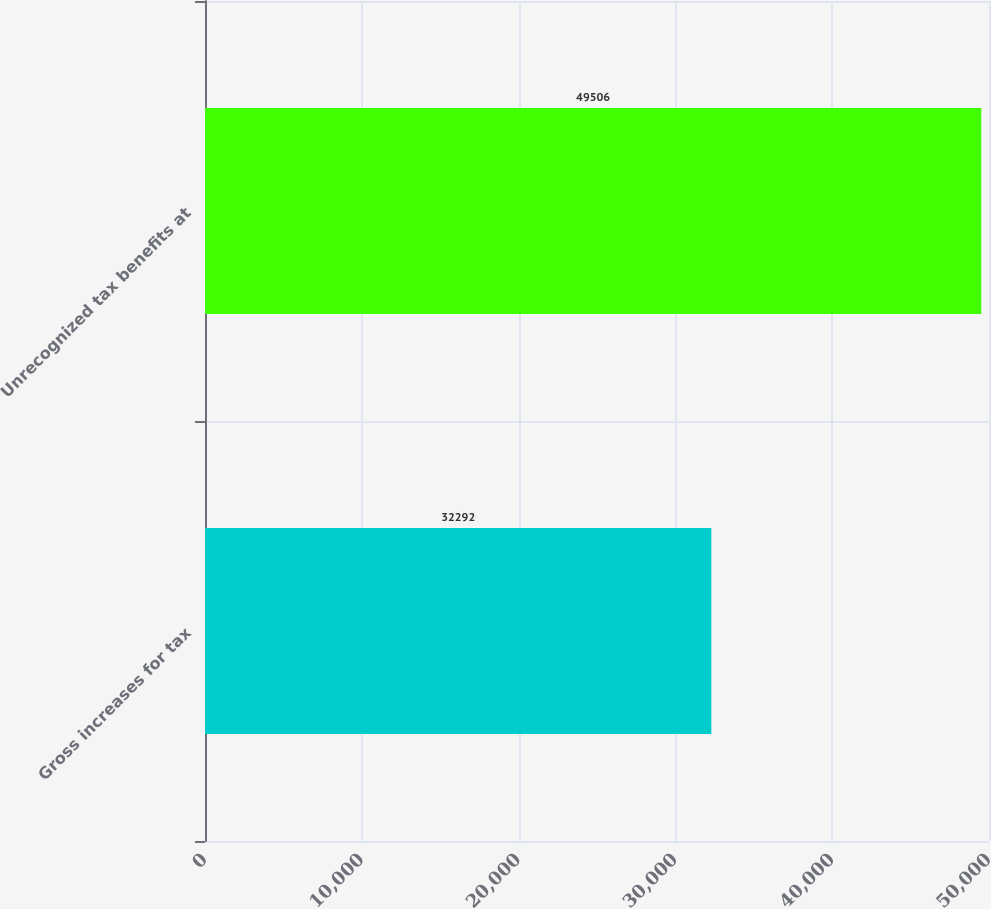Convert chart to OTSL. <chart><loc_0><loc_0><loc_500><loc_500><bar_chart><fcel>Gross increases for tax<fcel>Unrecognized tax benefits at<nl><fcel>32292<fcel>49506<nl></chart> 